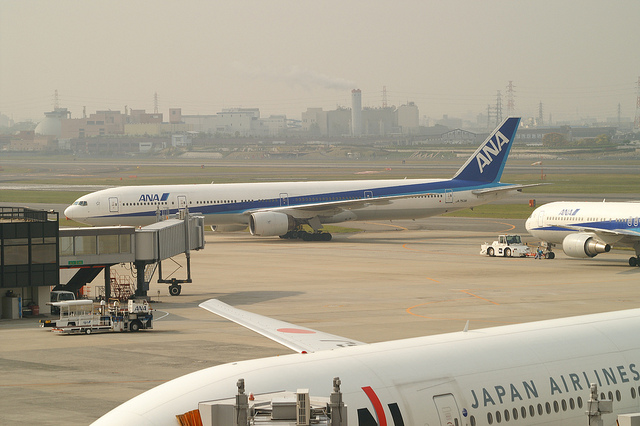How many airplanes are visible in this image? There are at least parts of three airplanes visible in this image. One is fully connected to the aerobridge, the second is partially visible at the bottom of the image, and the third is in the background behind the first airplane. 